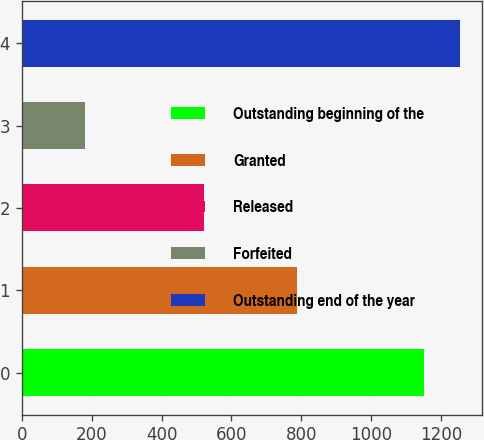<chart> <loc_0><loc_0><loc_500><loc_500><bar_chart><fcel>Outstanding beginning of the<fcel>Granted<fcel>Released<fcel>Forfeited<fcel>Outstanding end of the year<nl><fcel>1150<fcel>787<fcel>522<fcel>180<fcel>1255.5<nl></chart> 